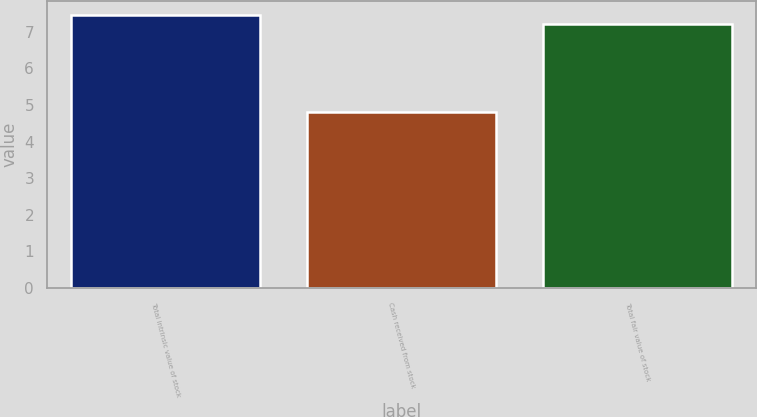Convert chart. <chart><loc_0><loc_0><loc_500><loc_500><bar_chart><fcel>Total intrinsic value of stock<fcel>Cash received from stock<fcel>Total fair value of stock<nl><fcel>7.46<fcel>4.8<fcel>7.2<nl></chart> 